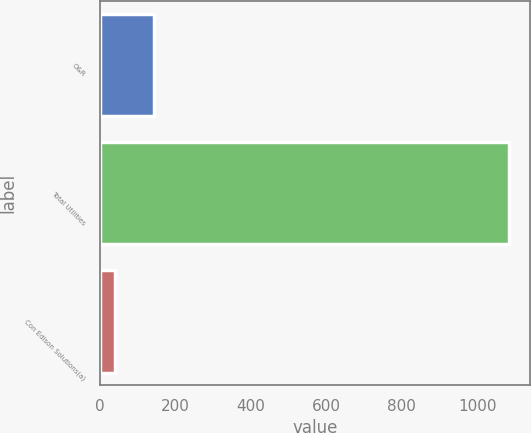Convert chart. <chart><loc_0><loc_0><loc_500><loc_500><bar_chart><fcel>O&R<fcel>Total Utilities<fcel>Con Edison Solutions(a)<nl><fcel>144.5<fcel>1085<fcel>40<nl></chart> 